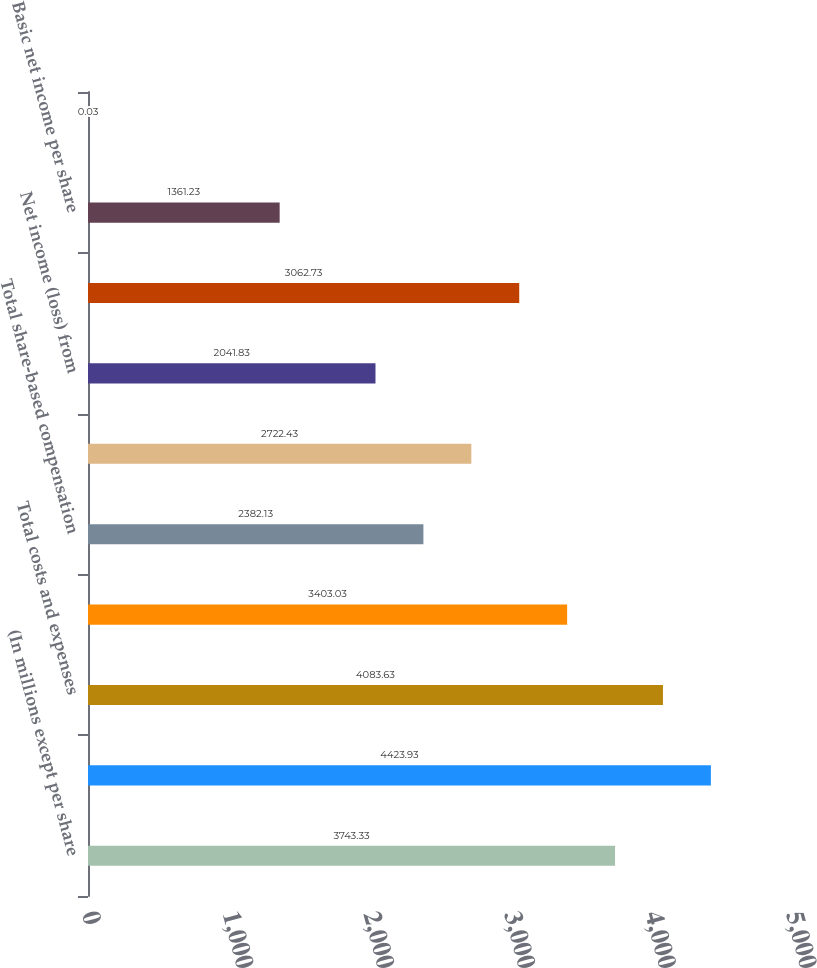<chart> <loc_0><loc_0><loc_500><loc_500><bar_chart><fcel>(In millions except per share<fcel>Total net revenue<fcel>Total costs and expenses<fcel>Operating income from<fcel>Total share-based compensation<fcel>Net income from continuing<fcel>Net income (loss) from<fcel>Net income<fcel>Basic net income per share<fcel>Basic net income (loss) per<nl><fcel>3743.33<fcel>4423.93<fcel>4083.63<fcel>3403.03<fcel>2382.13<fcel>2722.43<fcel>2041.83<fcel>3062.73<fcel>1361.23<fcel>0.03<nl></chart> 